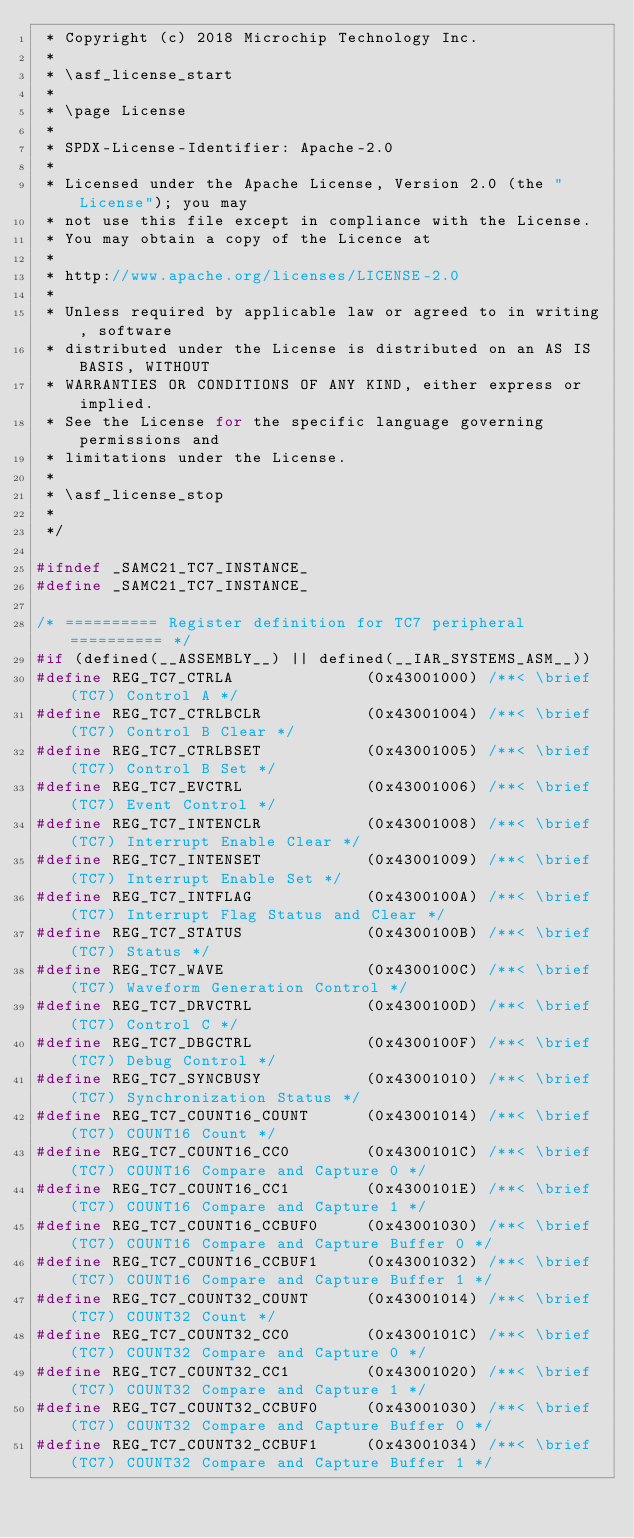Convert code to text. <code><loc_0><loc_0><loc_500><loc_500><_C_> * Copyright (c) 2018 Microchip Technology Inc.
 *
 * \asf_license_start
 *
 * \page License
 *
 * SPDX-License-Identifier: Apache-2.0
 *
 * Licensed under the Apache License, Version 2.0 (the "License"); you may
 * not use this file except in compliance with the License.
 * You may obtain a copy of the Licence at
 * 
 * http://www.apache.org/licenses/LICENSE-2.0
 * 
 * Unless required by applicable law or agreed to in writing, software
 * distributed under the License is distributed on an AS IS BASIS, WITHOUT
 * WARRANTIES OR CONDITIONS OF ANY KIND, either express or implied.
 * See the License for the specific language governing permissions and
 * limitations under the License.
 *
 * \asf_license_stop
 *
 */

#ifndef _SAMC21_TC7_INSTANCE_
#define _SAMC21_TC7_INSTANCE_

/* ========== Register definition for TC7 peripheral ========== */
#if (defined(__ASSEMBLY__) || defined(__IAR_SYSTEMS_ASM__))
#define REG_TC7_CTRLA              (0x43001000) /**< \brief (TC7) Control A */
#define REG_TC7_CTRLBCLR           (0x43001004) /**< \brief (TC7) Control B Clear */
#define REG_TC7_CTRLBSET           (0x43001005) /**< \brief (TC7) Control B Set */
#define REG_TC7_EVCTRL             (0x43001006) /**< \brief (TC7) Event Control */
#define REG_TC7_INTENCLR           (0x43001008) /**< \brief (TC7) Interrupt Enable Clear */
#define REG_TC7_INTENSET           (0x43001009) /**< \brief (TC7) Interrupt Enable Set */
#define REG_TC7_INTFLAG            (0x4300100A) /**< \brief (TC7) Interrupt Flag Status and Clear */
#define REG_TC7_STATUS             (0x4300100B) /**< \brief (TC7) Status */
#define REG_TC7_WAVE               (0x4300100C) /**< \brief (TC7) Waveform Generation Control */
#define REG_TC7_DRVCTRL            (0x4300100D) /**< \brief (TC7) Control C */
#define REG_TC7_DBGCTRL            (0x4300100F) /**< \brief (TC7) Debug Control */
#define REG_TC7_SYNCBUSY           (0x43001010) /**< \brief (TC7) Synchronization Status */
#define REG_TC7_COUNT16_COUNT      (0x43001014) /**< \brief (TC7) COUNT16 Count */
#define REG_TC7_COUNT16_CC0        (0x4300101C) /**< \brief (TC7) COUNT16 Compare and Capture 0 */
#define REG_TC7_COUNT16_CC1        (0x4300101E) /**< \brief (TC7) COUNT16 Compare and Capture 1 */
#define REG_TC7_COUNT16_CCBUF0     (0x43001030) /**< \brief (TC7) COUNT16 Compare and Capture Buffer 0 */
#define REG_TC7_COUNT16_CCBUF1     (0x43001032) /**< \brief (TC7) COUNT16 Compare and Capture Buffer 1 */
#define REG_TC7_COUNT32_COUNT      (0x43001014) /**< \brief (TC7) COUNT32 Count */
#define REG_TC7_COUNT32_CC0        (0x4300101C) /**< \brief (TC7) COUNT32 Compare and Capture 0 */
#define REG_TC7_COUNT32_CC1        (0x43001020) /**< \brief (TC7) COUNT32 Compare and Capture 1 */
#define REG_TC7_COUNT32_CCBUF0     (0x43001030) /**< \brief (TC7) COUNT32 Compare and Capture Buffer 0 */
#define REG_TC7_COUNT32_CCBUF1     (0x43001034) /**< \brief (TC7) COUNT32 Compare and Capture Buffer 1 */</code> 